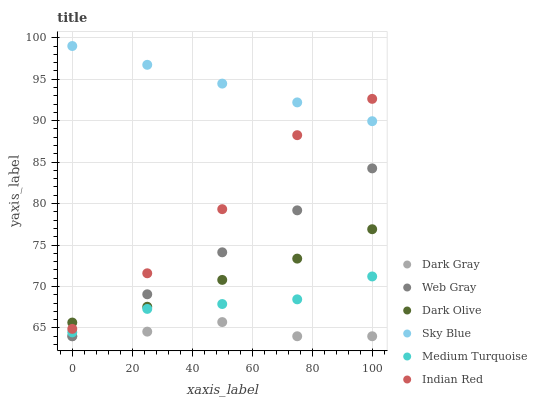Does Dark Gray have the minimum area under the curve?
Answer yes or no. Yes. Does Sky Blue have the maximum area under the curve?
Answer yes or no. Yes. Does Medium Turquoise have the minimum area under the curve?
Answer yes or no. No. Does Medium Turquoise have the maximum area under the curve?
Answer yes or no. No. Is Sky Blue the smoothest?
Answer yes or no. Yes. Is Indian Red the roughest?
Answer yes or no. Yes. Is Medium Turquoise the smoothest?
Answer yes or no. No. Is Medium Turquoise the roughest?
Answer yes or no. No. Does Web Gray have the lowest value?
Answer yes or no. Yes. Does Medium Turquoise have the lowest value?
Answer yes or no. No. Does Sky Blue have the highest value?
Answer yes or no. Yes. Does Medium Turquoise have the highest value?
Answer yes or no. No. Is Dark Gray less than Sky Blue?
Answer yes or no. Yes. Is Sky Blue greater than Web Gray?
Answer yes or no. Yes. Does Dark Olive intersect Web Gray?
Answer yes or no. Yes. Is Dark Olive less than Web Gray?
Answer yes or no. No. Is Dark Olive greater than Web Gray?
Answer yes or no. No. Does Dark Gray intersect Sky Blue?
Answer yes or no. No. 